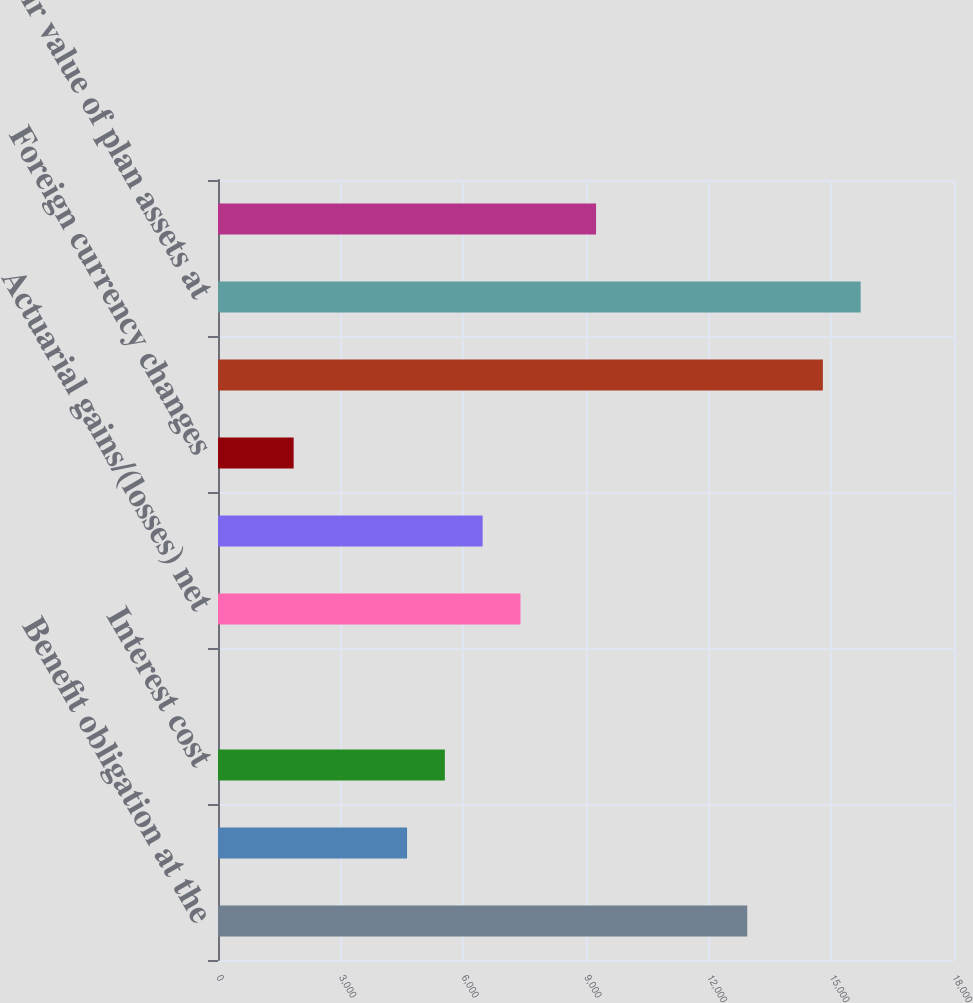<chart> <loc_0><loc_0><loc_500><loc_500><bar_chart><fcel>Benefit obligation at the<fcel>Service cost<fcel>Interest cost<fcel>Plan participants'<fcel>Actuarial gains/(losses) net<fcel>Benefits paid<fcel>Foreign currency changes<fcel>Benefit obligation at end of<fcel>Fair value of plan assets at<fcel>Actual return on plan assets<nl><fcel>12944<fcel>4623.5<fcel>5548<fcel>1<fcel>7397<fcel>6472.5<fcel>1850<fcel>14793<fcel>15717.5<fcel>9246<nl></chart> 